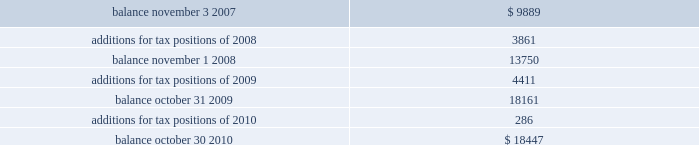Of global business , there are many transactions and calculations where the ultimate tax outcome is uncertain .
Some of these uncertainties arise as a consequence of cost reimbursement arrangements among related entities .
Although the company believes its estimates are reasonable , no assurance can be given that the final tax outcome of these matters will not be different than that which is reflected in the historical income tax provisions and accruals .
Such differences could have a material impact on the company 2019s income tax provision and operating results in the period in which such determination is made .
On november 4 , 2007 ( the first day of its 2008 fiscal year ) , the company adopted new accounting principles on accounting for uncertain tax positions .
These principles require companies to determine whether it is 201cmore likely than not 201d that a tax position will be sustained upon examination by the appropriate taxing authorities before any benefit can be recorded in the financial statements .
An uncertain income tax position will not be recognized if it has less than a 50% ( 50 % ) likelihood of being sustained .
There were no changes to the company 2019s liabilities for uncertain tax positions as a result of the adoption of these provisions .
As of october 30 , 2010 and october 31 , 2009 , the company had a liability of $ 18.4 million and $ 18.2 million , respectively , for gross unrealized tax benefits , all of which , if settled in the company 2019s favor , would lower the company 2019s effective tax rate in the period recorded .
In addition , as of october 30 , 2010 and october 31 , 2009 , the company had a liability of approximately $ 9.8 million and $ 8.0 million , respectively , for interest and penalties .
The total liability as of october 30 , 2010 and october 31 , 2009 of $ 28.3 million and $ 26.2 million , respectively , for uncertain tax positions is classified as non-current , and is included in other non-current liabilities , because the company believes that the ultimate payment or settlement of these liabilities will not occur within the next twelve months .
Prior to the adoption of these provisions , these amounts were included in current income tax payable .
The company includes interest and penalties related to unrecognized tax benefits within the provision for taxes in the condensed consolidated statements of income , and as a result , no change in classification was made upon adopting these provisions .
The condensed consolidated statements of income for fiscal years 2010 , 2009 and 2008 include $ 1.8 million , $ 1.7 million and $ 1.3 million , respectively , of interest and penalties related to these uncertain tax positions .
Due to the complexity associated with its tax uncertainties , the company cannot make a reasonably reliable estimate as to the period in which it expects to settle the liabilities associated with these uncertain tax positions .
The table summarizes the changes in the total amounts of uncertain tax positions for fiscal 2008 through fiscal 2010. .
Fiscal years 2004 and 2005 irs examination during the fourth quarter of fiscal 2007 , the irs completed its field examination of the company 2019s fiscal years 2004 and 2005 .
On january 2 , 2008 , the irs issued its report for fiscal 2004 and 2005 , which included proposed adjustments related to these two fiscal years .
The company has recorded taxes and penalties related to certain of these proposed adjustments .
There are four items with an additional potential total tax liability of $ 46 million .
The company has concluded , based on discussions with its tax advisors , that these four items are not likely to result in any additional tax liability .
Therefore , the company has not recorded any additional tax liability for these items and is appealing these proposed adjustments through the normal processes for the resolution of differences between the irs and taxpayers .
The company 2019s initial meetings with the appellate division of the irs were held during fiscal analog devices , inc .
Notes to consolidated financial statements 2014 ( continued ) .
How is the net cash flow from operations affected by the change in liability of interest and penalties in 2010? 
Computations: (9.8 - 8.0)
Answer: 1.8. 